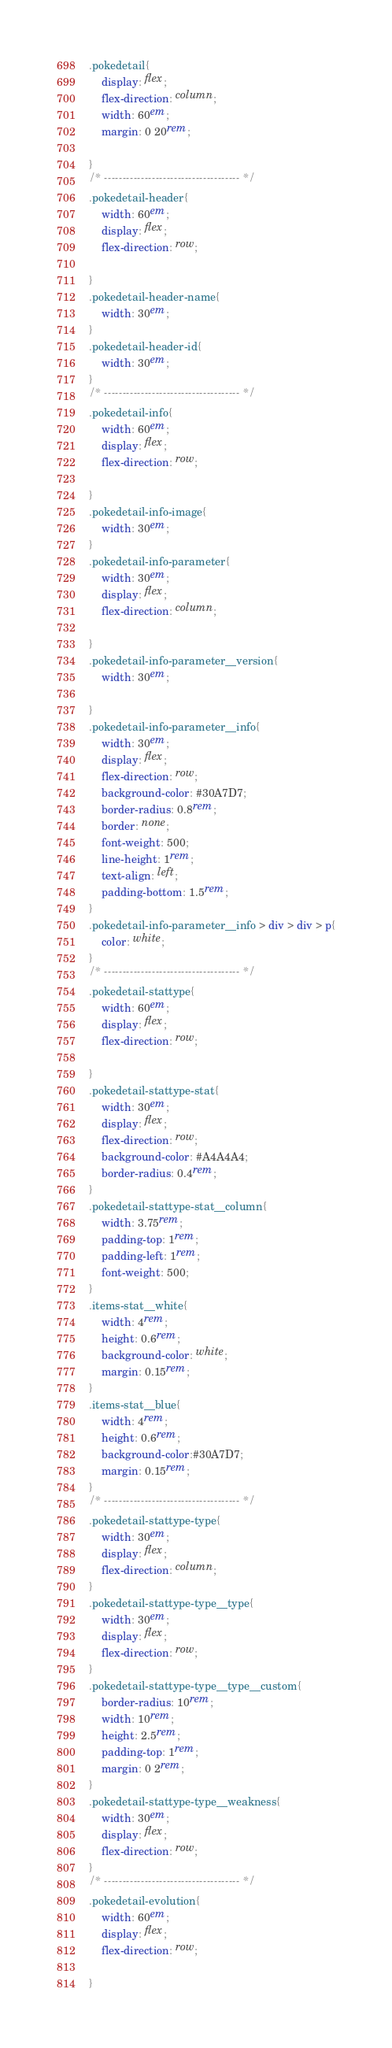Convert code to text. <code><loc_0><loc_0><loc_500><loc_500><_CSS_>.pokedetail{
    display: flex;
    flex-direction: column;
    width: 60em;
    margin: 0 20rem;
    
}
/* ------------------------------------- */
.pokedetail-header{
    width: 60em;
    display: flex;
    flex-direction: row;
    
}
.pokedetail-header-name{
    width: 30em;
}
.pokedetail-header-id{
    width: 30em;
}
/* ------------------------------------- */
.pokedetail-info{
    width: 60em;
    display: flex;
    flex-direction: row;
    
}
.pokedetail-info-image{
    width: 30em;
}
.pokedetail-info-parameter{
    width: 30em;
    display: flex;
    flex-direction: column;
    
}
.pokedetail-info-parameter__version{
    width: 30em;
    
}
.pokedetail-info-parameter__info{
    width: 30em;
    display: flex;
    flex-direction: row;
    background-color: #30A7D7;
    border-radius: 0.8rem;
    border: none;
    font-weight: 500;
    line-height: 1rem;
    text-align: left;
    padding-bottom: 1.5rem;
}
.pokedetail-info-parameter__info > div > div > p{
    color: white;
}
/* ------------------------------------- */
.pokedetail-stattype{
    width: 60em;
    display: flex;
    flex-direction: row;
    
}
.pokedetail-stattype-stat{
    width: 30em;
    display: flex;
    flex-direction: row;
    background-color: #A4A4A4;
    border-radius: 0.4rem;
}
.pokedetail-stattype-stat__column{
    width: 3.75rem;
    padding-top: 1rem;
    padding-left: 1rem;
    font-weight: 500;
}
.items-stat__white{
    width: 4rem;
    height: 0.6rem;
    background-color: white;
    margin: 0.15rem;
}
.items-stat__blue{
    width: 4rem;
    height: 0.6rem;
    background-color:#30A7D7;
    margin: 0.15rem;
}
/* ------------------------------------- */
.pokedetail-stattype-type{
    width: 30em;
    display: flex;
    flex-direction: column;
}
.pokedetail-stattype-type__type{
    width: 30em;
    display: flex;
    flex-direction: row;
}
.pokedetail-stattype-type__type__custom{
    border-radius: 10rem;
    width: 10rem;
    height: 2.5rem;
    padding-top: 1rem;
    margin: 0 2rem;
}
.pokedetail-stattype-type__weakness{
    width: 30em;
    display: flex;
    flex-direction: row;
}
/* ------------------------------------- */
.pokedetail-evolution{
    width: 60em;
    display: flex;
    flex-direction: row;
    
}</code> 